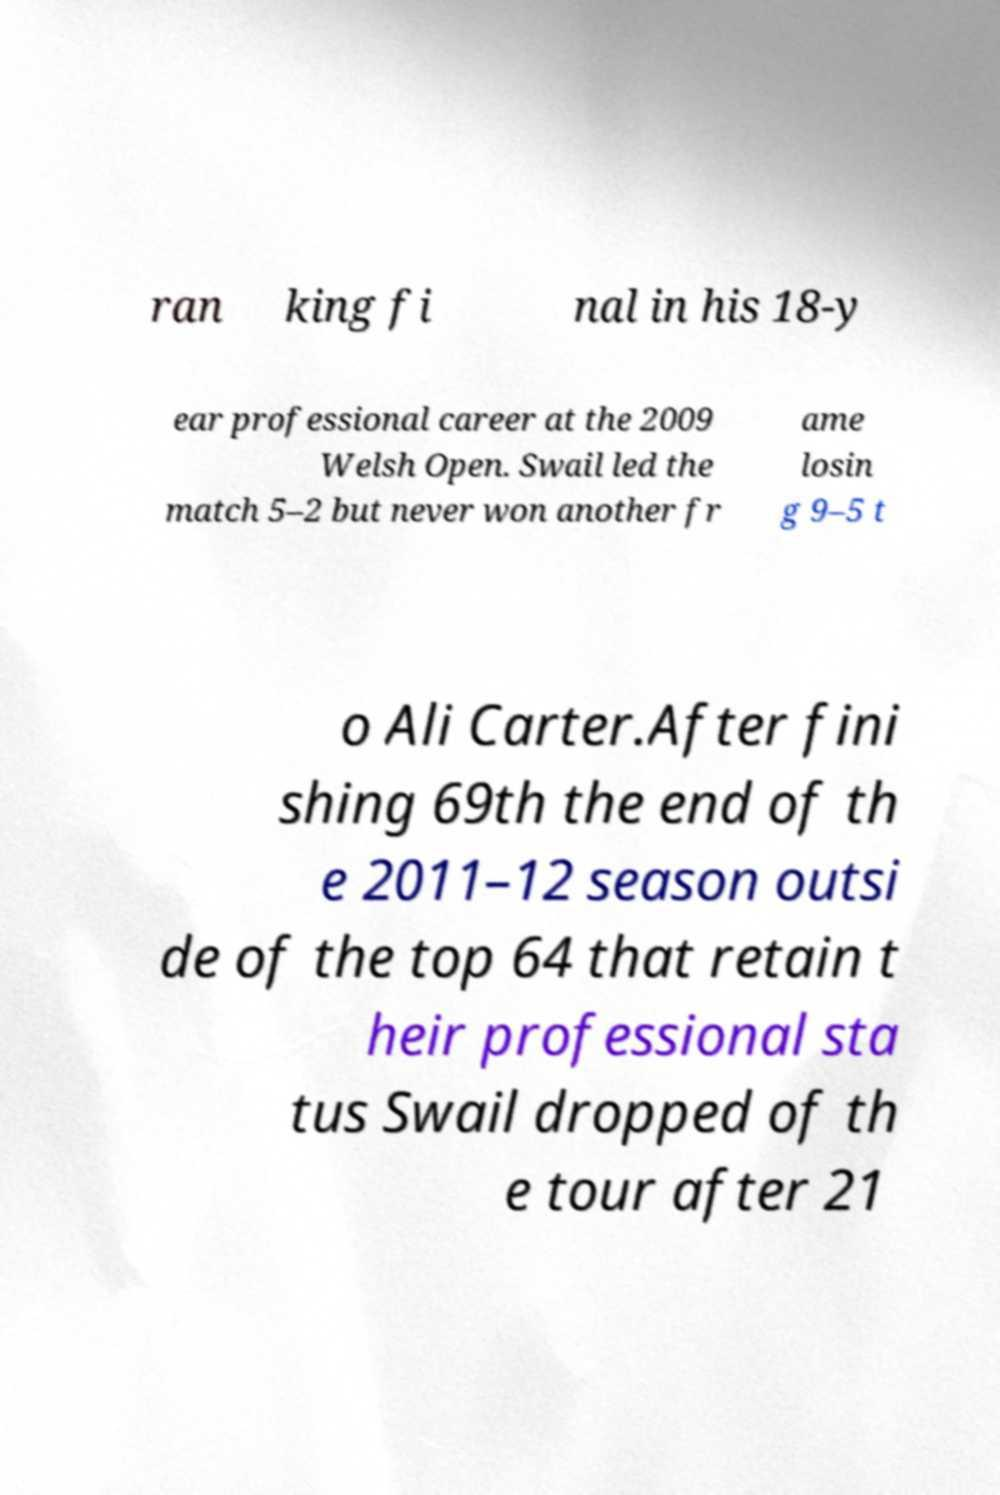I need the written content from this picture converted into text. Can you do that? ran king fi nal in his 18-y ear professional career at the 2009 Welsh Open. Swail led the match 5–2 but never won another fr ame losin g 9–5 t o Ali Carter.After fini shing 69th the end of th e 2011–12 season outsi de of the top 64 that retain t heir professional sta tus Swail dropped of th e tour after 21 